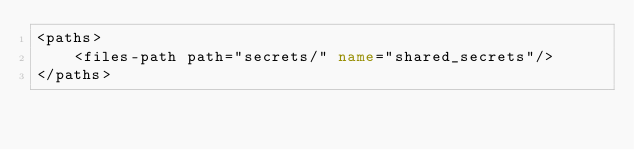Convert code to text. <code><loc_0><loc_0><loc_500><loc_500><_XML_><paths>
    <files-path path="secrets/" name="shared_secrets"/>
</paths>
</code> 